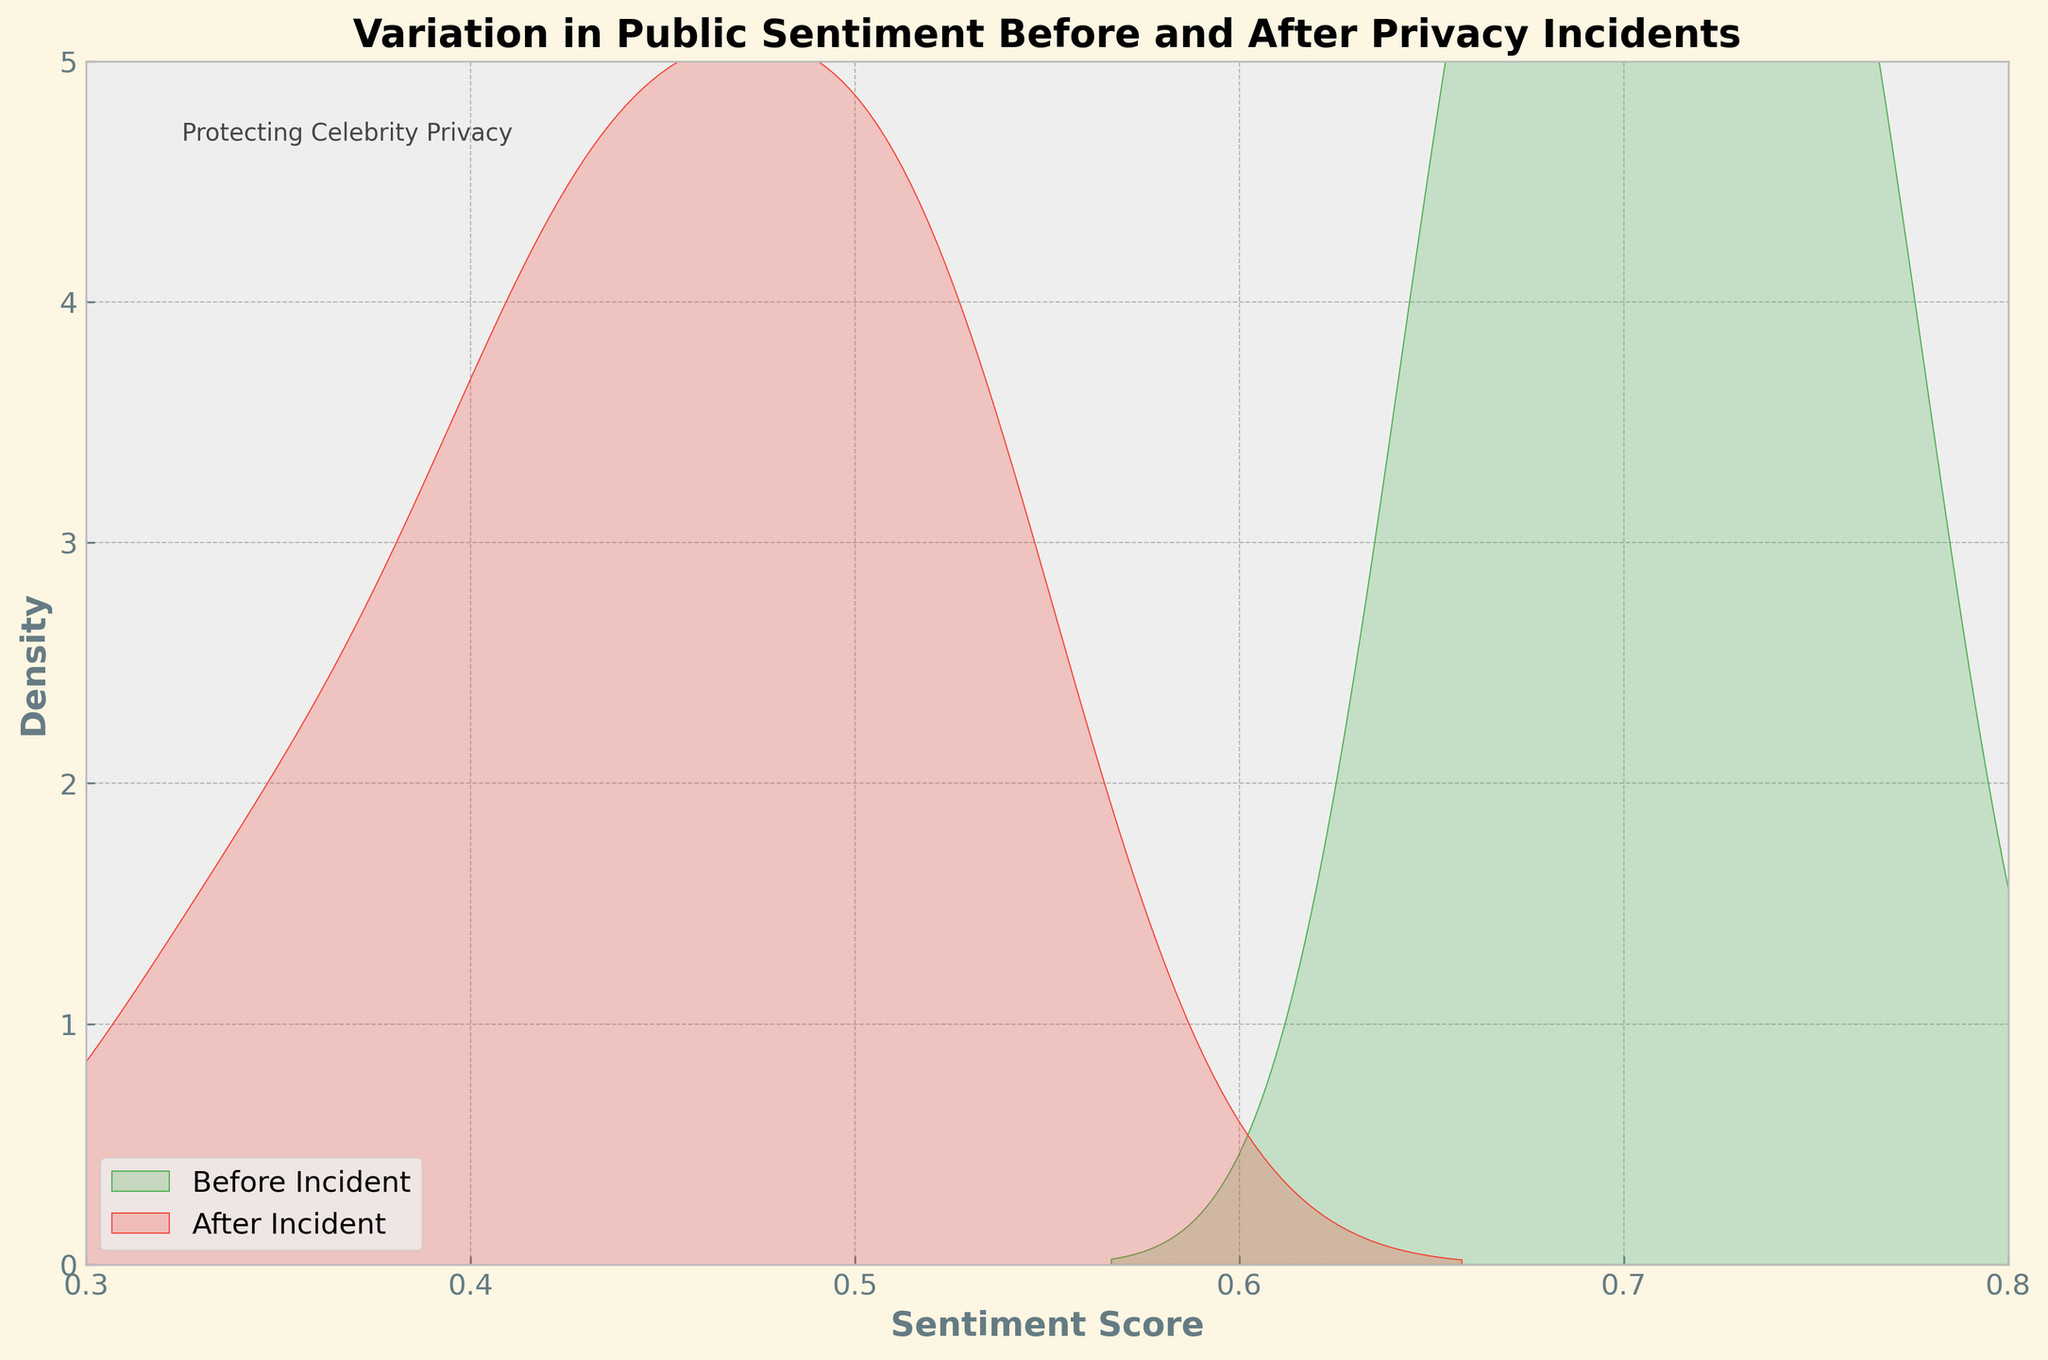What is the title of the plot? The title of the plot is prominently displayed at the top center. It reads "Variation in Public Sentiment Before and After Privacy Incidents".
Answer: Variation in Public Sentiment Before and After Privacy Incidents What colors represent the periods before and after privacy incidents? The plot uses two different colors to distinguish the periods: green for "Before Privacy Incident" and red for "After Privacy Incident". These colors fill the density areas under each corresponding line.
Answer: Green and Red What are the x-axis and y-axis labels? The x-axis is labeled "Sentiment Score" and the y-axis is labeled "Density". These labels help identify what each axis represents in the context of the plot.
Answer: Sentiment Score and Density What is the range of sentiment scores depicted in the plot? The x-axis ranges from 0.3 to 0.8, representing the range of sentiment scores shown in the density plot.
Answer: 0.3 to 0.8 Which period has the higher peak in the density plot? By looking at the height of the density curves, the "Before Privacy Incident" period, represented by the green color, has a higher peak compared to the "After Privacy Incident" period, represented by the red color.
Answer: Before Privacy Incident How does the density of sentiment scores below 0.5 compare for the two periods? The density of sentiment scores below 0.5 is higher for the "After Privacy Incident" period, indicated by the red shaded area being more pronounced in that region compared to the green shaded area for the "Before Privacy Incident" period.
Answer: After Privacy Incident What is the approximate peak density value for the "Before Privacy Incident" period? The green density curve for the "Before Privacy Incident" period peaks around the value of approximately 4 in the y-axis.
Answer: Approximately 4 Which period shows a wider spread of sentiment scores? The "After Privacy Incident" period, depicted by the red color, shows a wider spread of sentiment scores, as the density distribution is more spread out compared to the narrower green distribution of the "Before Privacy Incident" period.
Answer: After Privacy Incident Where is the annotation "Protecting Celebrity Privacy" placed? The annotation "Protecting Celebrity Privacy" is placed in the upper-left corner of the plot at around the coordinates (0.05, 0.95) within the axis area.
Answer: Upper-left corner Considering the x-axis range, in which period do sentiment scores tend to be higher on average? By observing the density peaks, the "Before Privacy Incident" period has sentiment scores that tend to be higher on average, indicated by the green peak being positioned more to the right compared to the red peak of the "After Privacy Incident" period.
Answer: Before Privacy Incident 